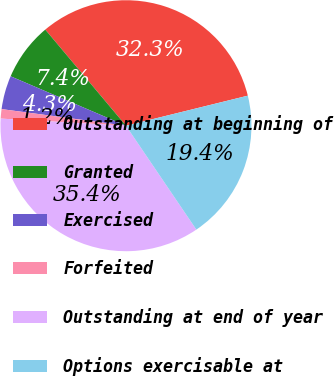Convert chart. <chart><loc_0><loc_0><loc_500><loc_500><pie_chart><fcel>Outstanding at beginning of<fcel>Granted<fcel>Exercised<fcel>Forfeited<fcel>Outstanding at end of year<fcel>Options exercisable at<nl><fcel>32.27%<fcel>7.44%<fcel>4.33%<fcel>1.21%<fcel>35.38%<fcel>19.37%<nl></chart> 